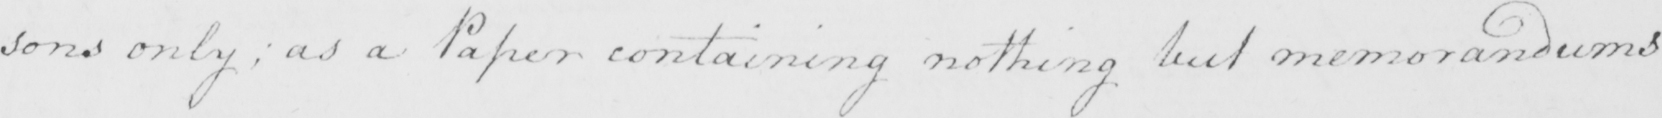Can you tell me what this handwritten text says? =sons only  ; as a Paper containing nothing but memorandums 